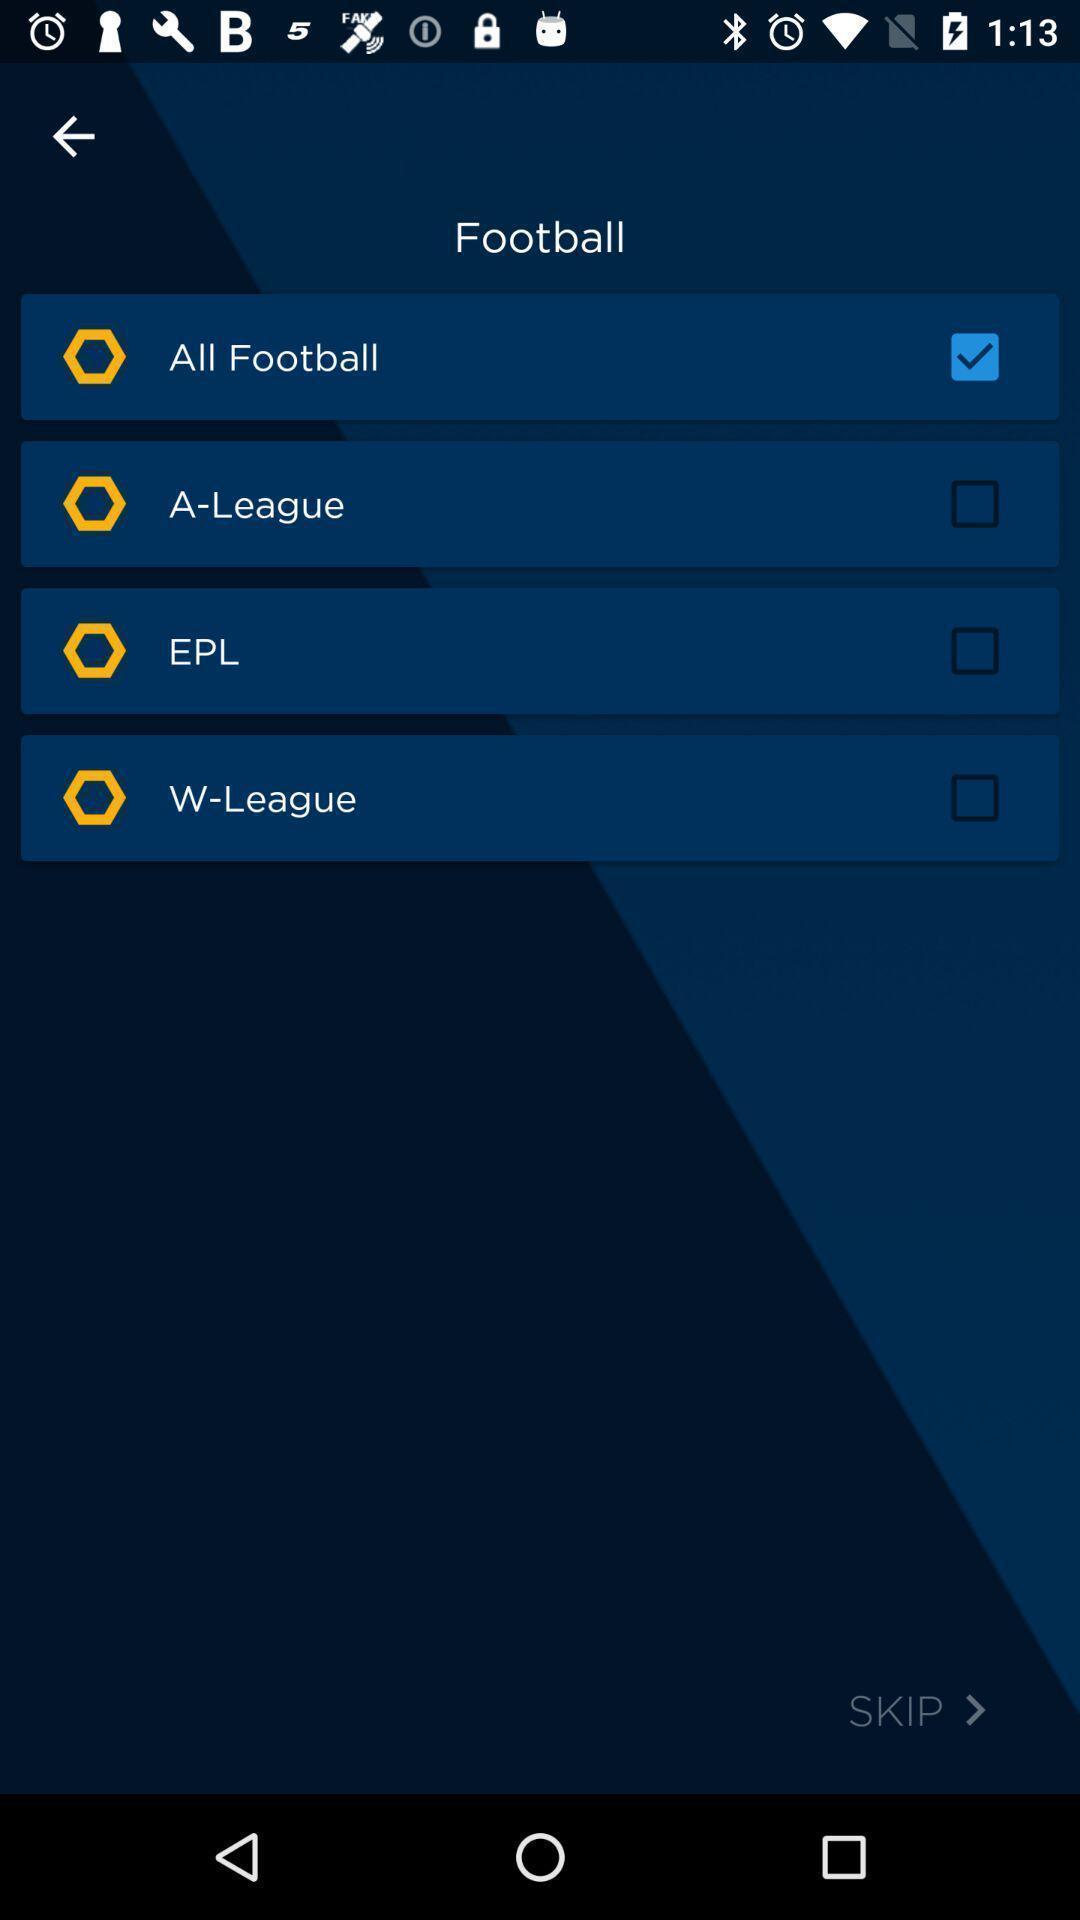Provide a description of this screenshot. Sport app displayed to enable different options. 